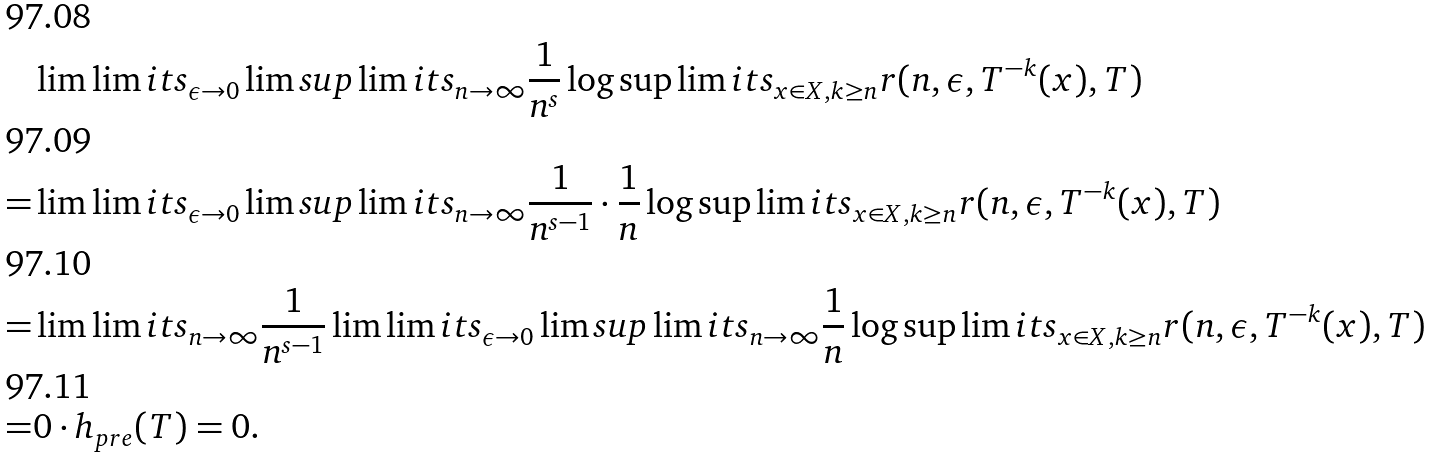Convert formula to latex. <formula><loc_0><loc_0><loc_500><loc_500>& \lim \lim i t s _ { \epsilon \to 0 } \lim s u p \lim i t s _ { n \to \infty } \frac { 1 } { n ^ { s } } \log \sup \lim i t s _ { x \in X , k \geq n } r ( n , \epsilon , T ^ { - k } ( x ) , T ) \\ = & \lim \lim i t s _ { \epsilon \to 0 } \lim s u p \lim i t s _ { n \to \infty } \frac { 1 } { n ^ { s - 1 } } \cdot \frac { 1 } { n } \log \sup \lim i t s _ { x \in X , k \geq n } r ( n , \epsilon , T ^ { - k } ( x ) , T ) \\ = & \lim \lim i t s _ { n \to \infty } \frac { 1 } { n ^ { s - 1 } } \lim \lim i t s _ { \epsilon \to 0 } \lim s u p \lim i t s _ { n \to \infty } \frac { 1 } { n } \log \sup \lim i t s _ { x \in X , k \geq n } r ( n , \epsilon , T ^ { - k } ( x ) , T ) \\ = & 0 \cdot h _ { p r e } ( T ) = 0 .</formula> 